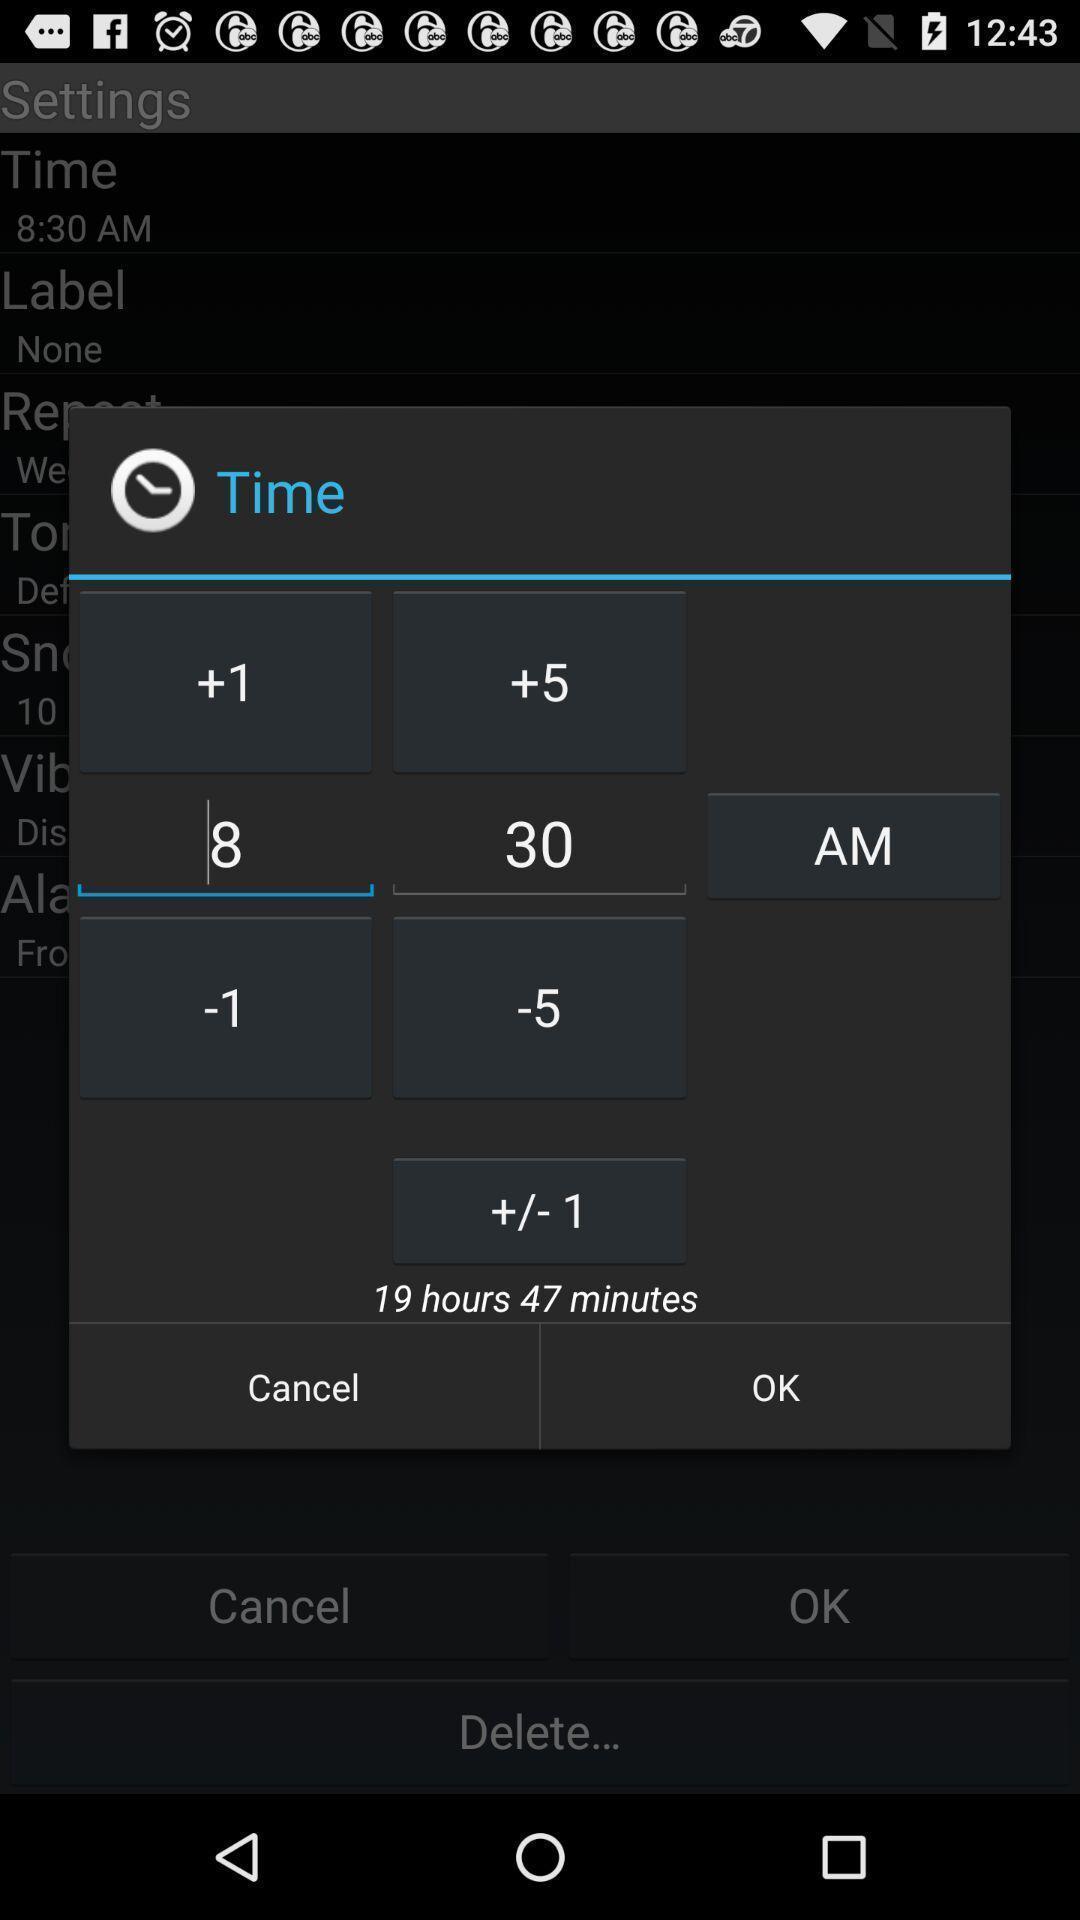Tell me what you see in this picture. Pop-up shows time setting in app. 